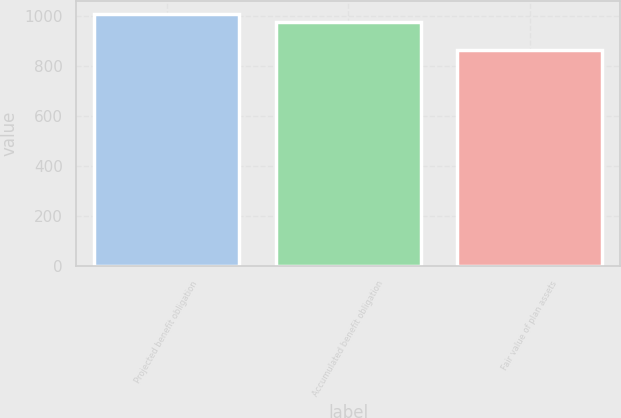Convert chart to OTSL. <chart><loc_0><loc_0><loc_500><loc_500><bar_chart><fcel>Projected benefit obligation<fcel>Accumulated benefit obligation<fcel>Fair value of plan assets<nl><fcel>1007<fcel>976<fcel>864<nl></chart> 